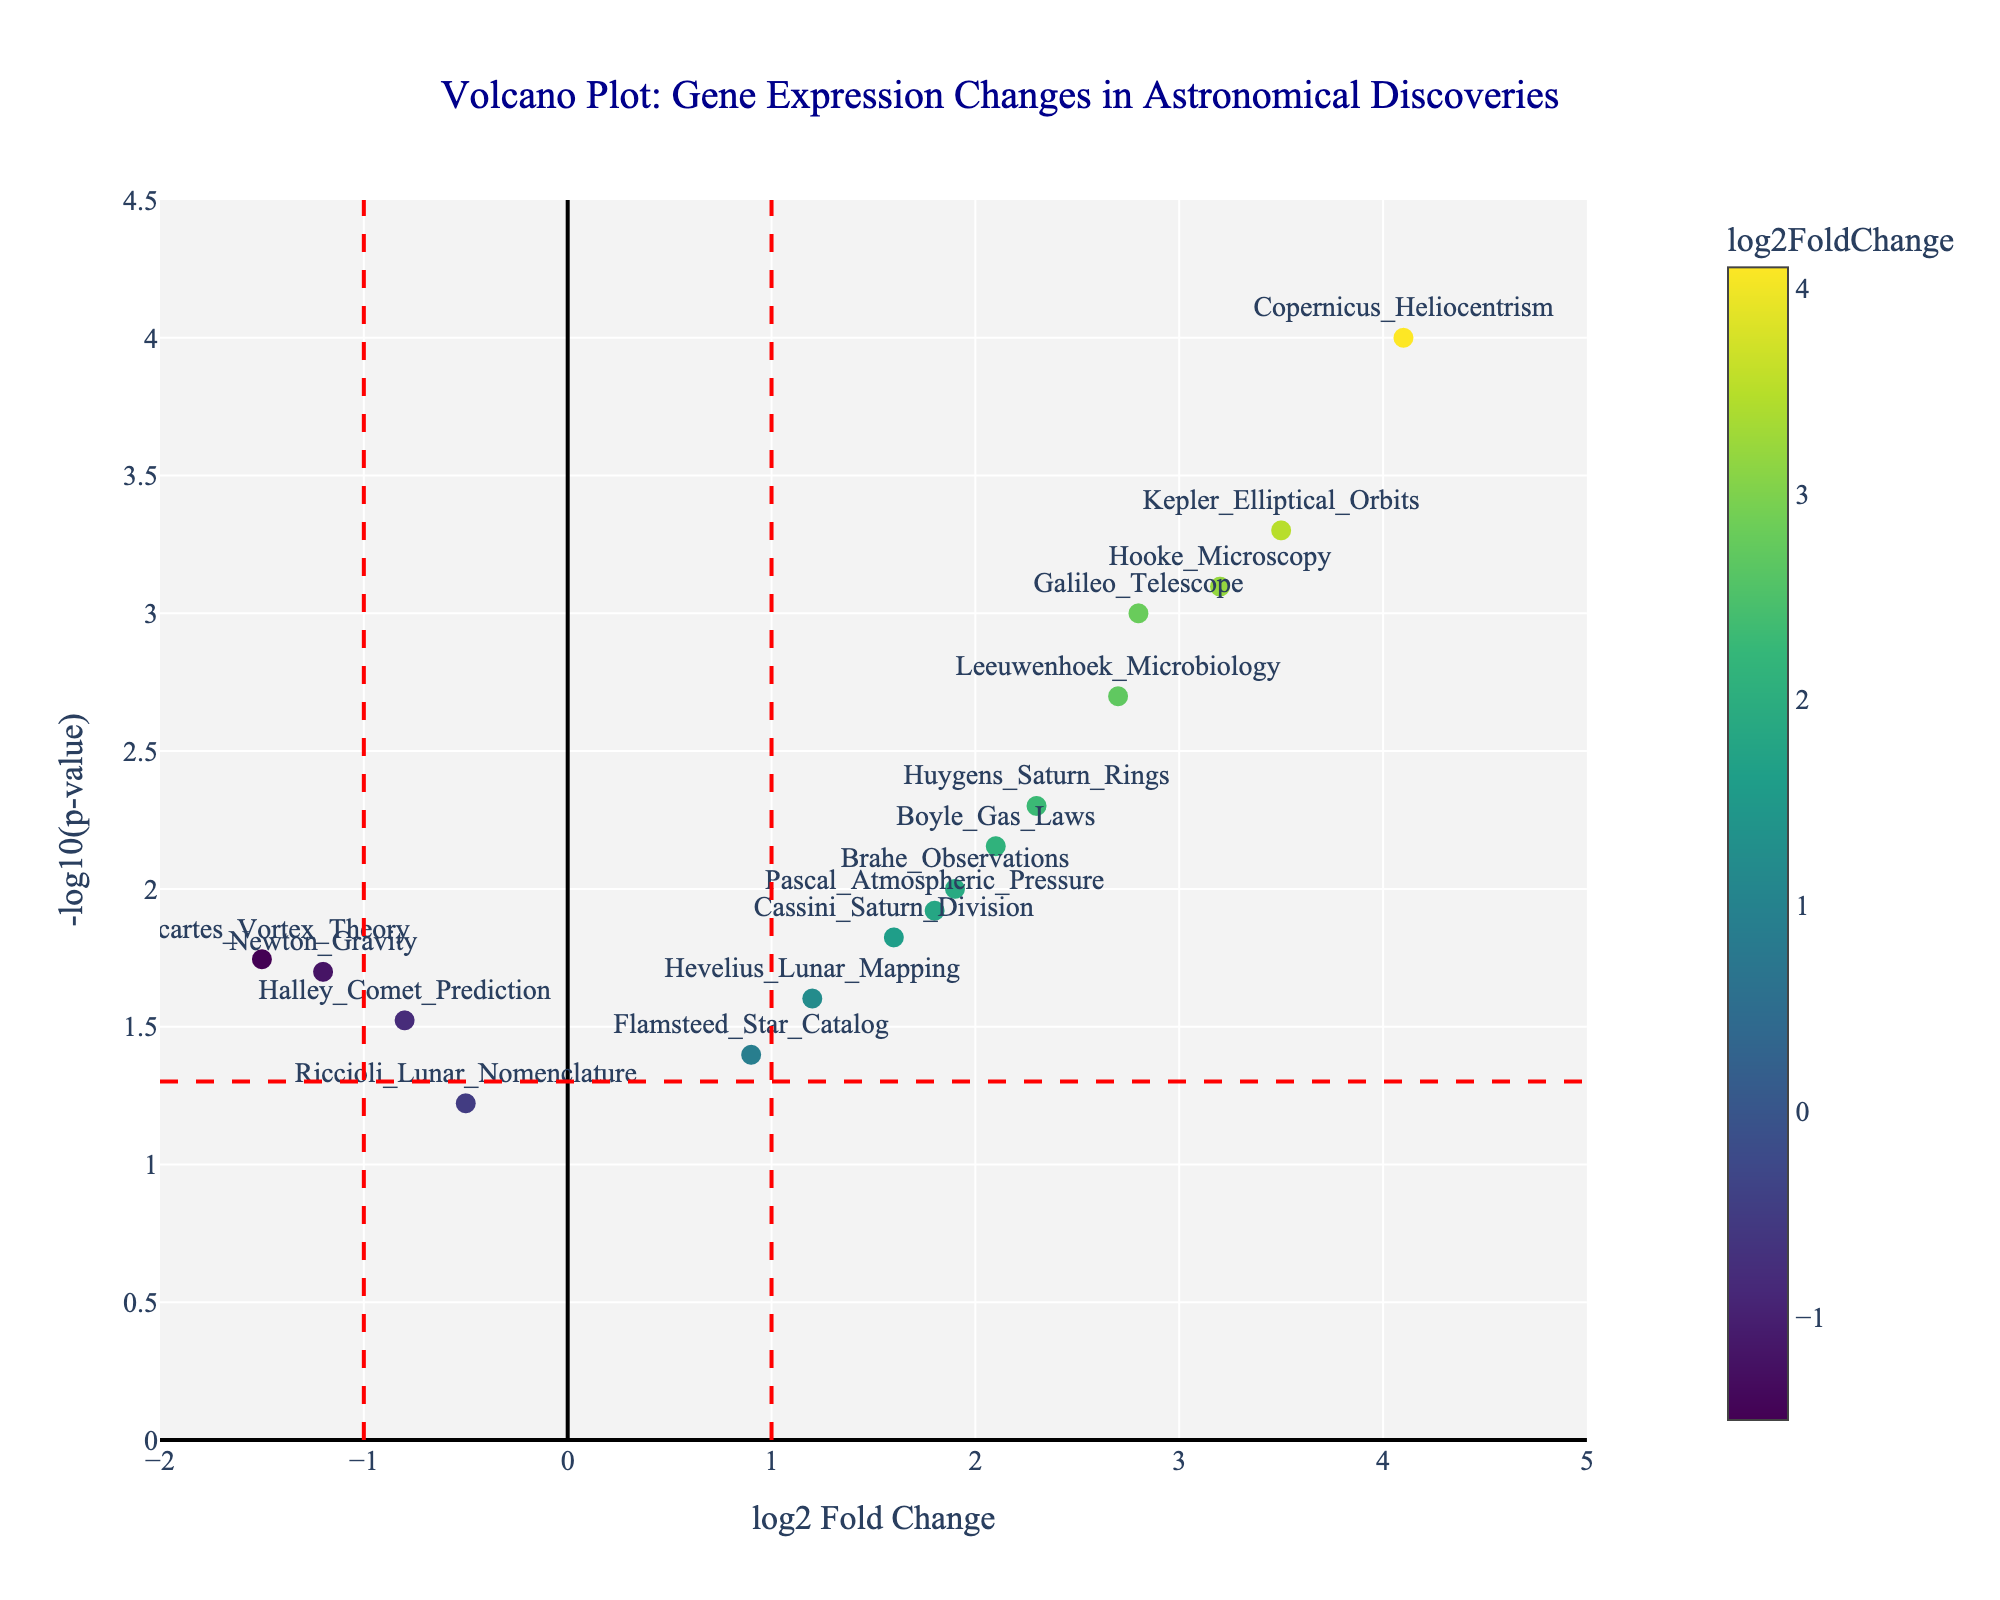What is the title of the plot? The plot's title is located at the top of the figure and states the main subject of the plot. In this case, it is "Volcano Plot: Gene Expression Changes in Astronomical Discoveries".
Answer: Volcano Plot: Gene Expression Changes in Astronomical Discoveries What are the x and y axes titles of the plot? The titles of the axes are crucial for understanding what each axis represents. In this figure, the x-axis represents "log2 Fold Change" and the y-axis represents "-log10(p-value)".
Answer: log2 Fold Change, -log10(p-value) How many data points have a significant p-value below 0.05? To determine this, identify the data points that lie above the horizontal red dashed line, which represents a p-value threshold of 0.05.
Answer: 14 Which data point has the highest log2 fold change? To find this, look at the farthest point on the right side on the x-axis. The data point with the highest log2 fold change is Copernicus_Heliocentrism.
Answer: Copernicus_Heliocentrism Which data point has the most negative log2 fold change? Identify the point that is farthest to the left on the x-axis, which will be the point with the most negative log2 fold change. This is Descartes_Vortex_Theory.
Answer: Descartes_Vortex_Theory How does Hooke_Microscopy compare with Leeuwenhoek_Microbiology in terms of log2 fold change? Compare the x-axis positions of the points labeled Hooke_Microscopy and Leeuwenhoek_Microbiology to see which has a higher log2 fold change. Hooke_Microscopy is higher with a log2 fold change of 3.2 compared to Leeuwenhoek_Microbiology’s 2.7.
Answer: Hooke_Microscopy has a higher fold change Which data points have a p-value between 0.01 and 0.05? Identify the points whose y-values (-log10(p-value)) lie between -log10(0.05) and -log10(0.01). These are Brahe_Observations, Cassini_Saturn_Division, Pascal_Atmospheric_Pressure, Hevelius_Lunar_Mapping, Halley_Comet_Prediction, Flamsteed_Star_Catalog, and Riccioli_Lunar_Nomenclature.
Answer: Brahe_Observations, Cassini_Saturn_Division, Pascal_Atmospheric_Pressure, Hevelius_Lunar_Mapping, Halley_Comet_Prediction, Flamsteed_Star_Catalog, Riccioli_Lunar_Nomenclature What is the log2 fold change of Galileo_Telescope’s discovery, and is it considered significant? Find Galileo_Telescope on the plot and read its position on the x-axis (log2 fold change) and check whether its p-value is below the significance threshold (above the horizontal red dashed line). The log2 fold change is 2.8 and it is significant as it is above the 0.05 p-value threshold.
Answer: 2.8, Yes Which data points are both below a p-value of 0.001 and have a log2 fold change greater than 2? Identify the points that lie above the vertical red dashed line at log2 fold change of 2 and above the horizontal red dashed line indicating -log10(0.001). These points are Galileo_Telescope, Hooke_Microscopy, and Copernicus_Heliocentrism.
Answer: Galileo_Telescope, Hooke_Microscopy, Copernicus_Heliocentrism How does the expression change for Newton_Gravity compare with Boyle_Gas_Laws in terms of both log2 fold change and p-value? Compare x and y coordinates of both points. Newton_Gravity has a log2 fold change of -1.2 and p-value of 0.02, while Boyle_Gas_Laws has a log2 fold change of 2.1 and p-value of 0.007. Therefore, Newton_Gravity shows a downregulation (negative fold change), and Boyle_Gas_Laws shows an upregulation with a lower (more significant) p-value.
Answer: Newton_Gravity is downregulated at a higher p-value, Boyle_Gas_Laws is upregulated at a lower p-value 